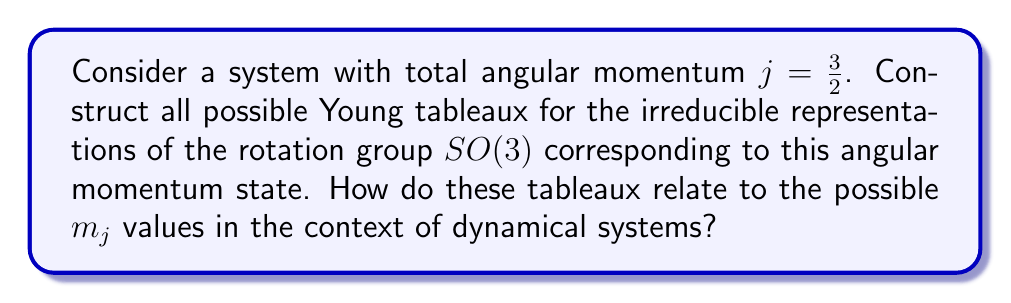Show me your answer to this math problem. To construct the Young tableaux for the representations of the rotation group in angular momentum theory, we follow these steps:

1) For a given total angular momentum $j$, the possible $m_j$ values range from $-j$ to $+j$ in integer steps. In this case, for $j = \frac{3}{2}$, we have:

   $m_j = -\frac{3}{2}, -\frac{1}{2}, \frac{1}{2}, \frac{3}{2}$

2) In the Young tableaux representation, each box represents a "spin up" state. The number of boxes in a single row tableau corresponds to $2j$.

3) For $j = \frac{3}{2}$, we need a tableau with 3 boxes in a single row:

   $$\yng(3)$$

4) This single tableau represents the entire $j = \frac{3}{2}$ multiplet.

5) The relation to $m_j$ values is as follows:
   - The fully filled tableau corresponds to the highest $m_j$ value ($\frac{3}{2}$).
   - Removing one box gives $m_j = \frac{1}{2}$.
   - Removing two boxes gives $m_j = -\frac{1}{2}$.
   - The empty tableau (not usually drawn) corresponds to $m_j = -\frac{3}{2}$.

6) In the context of dynamical systems, these tableaux represent the possible states of the angular momentum vector in 3D space. Each state corresponds to a different orientation of the angular momentum vector, which can be crucial in understanding the system's rotational dynamics.

7) The symmetry properties of the Young tableaux reflect the transformation properties of the angular momentum states under rotations, which is fundamental in analyzing the evolution of rotating systems in phase space.
Answer: Single row Young tableau with 3 boxes: $$\yng(3)$$ 